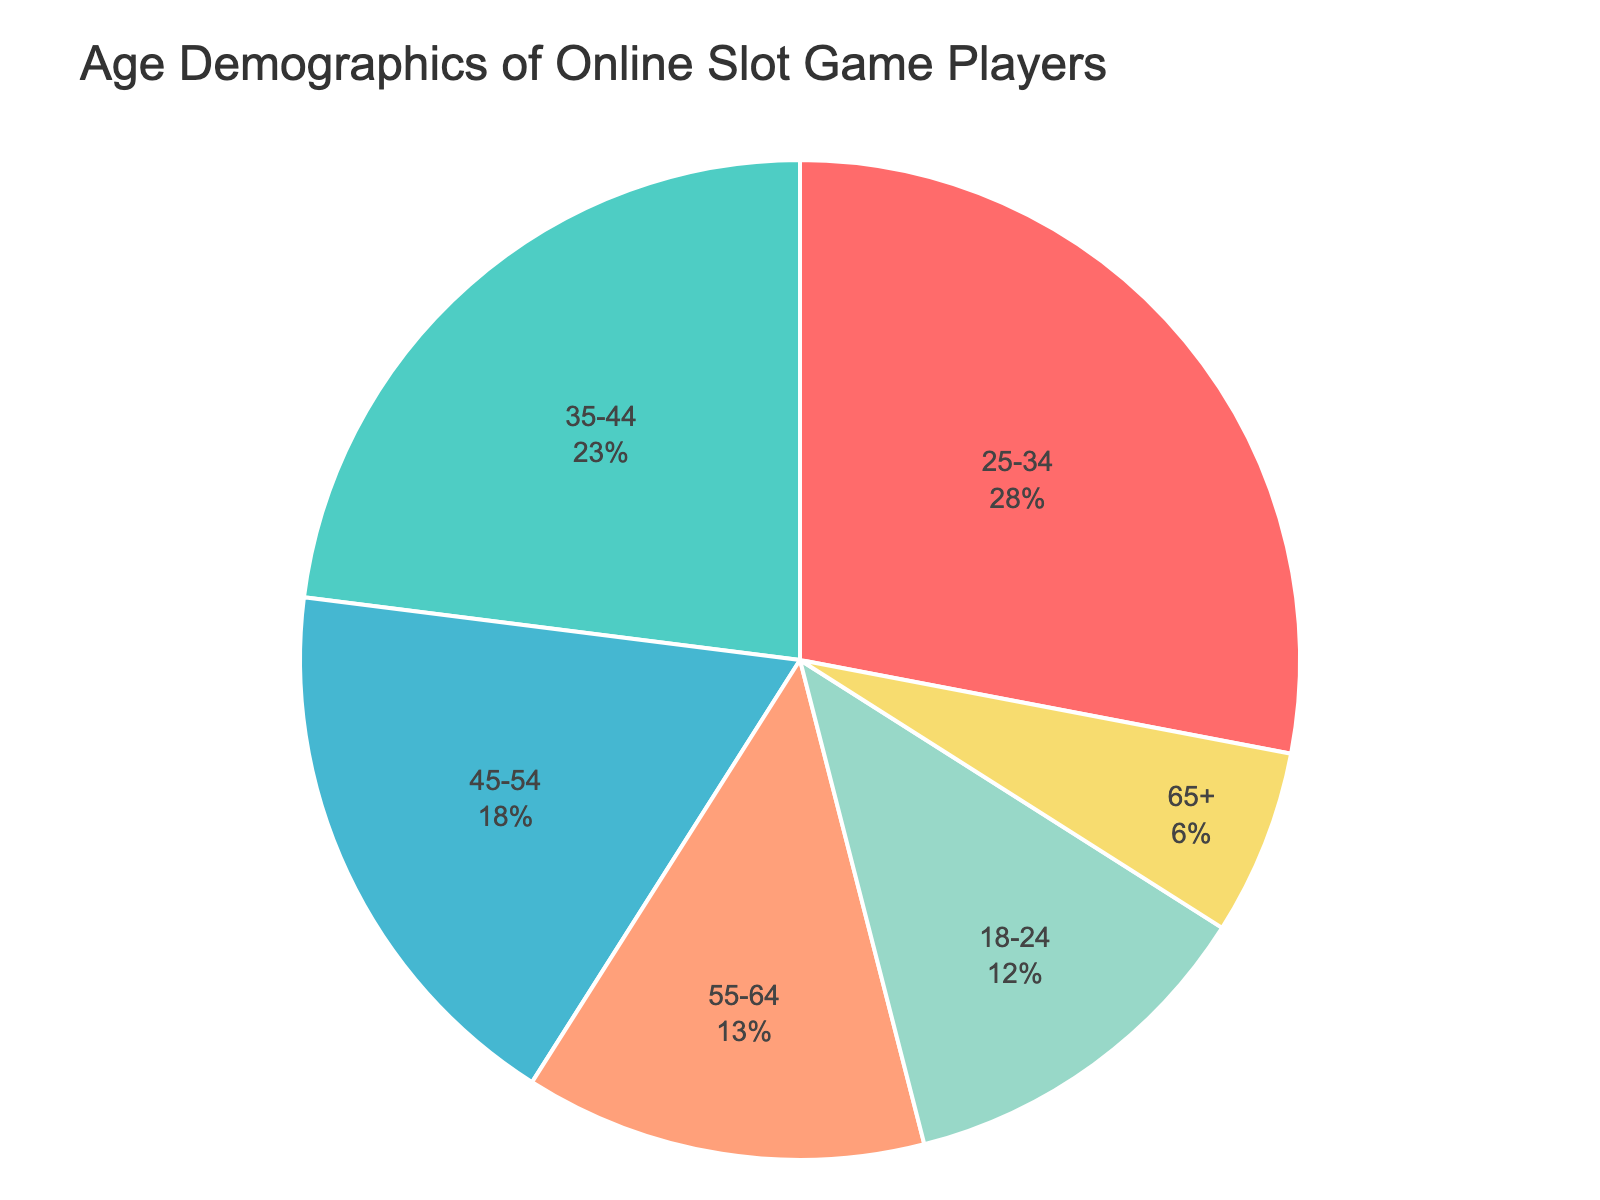What percentage of online slot game players are aged 35-44? Look at the section of the pie chart labeled "35-44". The text inside the section shows the percentage.
Answer: 23% Which age group has the highest percentage of players? Examine the size of the pie chart sections and identify the one with the largest area. The label inside the largest section reads "25-34".
Answer: 25-34 What is the combined percentage of players aged 45-54 and 55-64? Sum the percentages of the 45-54 and 55-64 age groups: 18% + 13%.
Answer: 31% Are there more players aged 18-24 or 65+? Compare the sizes of the "18-24" and "65+" sections in the pie chart. Notice that "18-24" has a larger area.
Answer: 18-24 How much larger is the percentage of players aged 25-34 compared to those aged 55-64? Subtract the percentage of 55-64 from that of 25-34: 28% - 13%.
Answer: 15% If you combine the age groups 35-44 and 45-54, what percentage of the total players do they make up? Add the percentages of the 35-44 and 45-54 age groups: 23% + 18%.
Answer: 41% Which age group constitutes less than 10% of the total players? Look for pie chart sections with percentages less than 10%. The label inside the "65+" section shows it is 6%.
Answer: 65+ What is the difference in percentage between the largest and smallest age groups? Find the largest percentage (25-34, 28%) and the smallest percentage (65+, 6%) and subtract them: 28% - 6%.
Answer: 22% How does the percentage of players aged 35-44 compare to those aged 45-54? Compare the percentages of the 35-44 (23%) and the 45-54 (18%) groups.
Answer: 35-44 is higher What is the total percentage of players aged under 35? Add the percentages of the 18-24 and 25-34 age groups: 12% + 28%.
Answer: 40% 